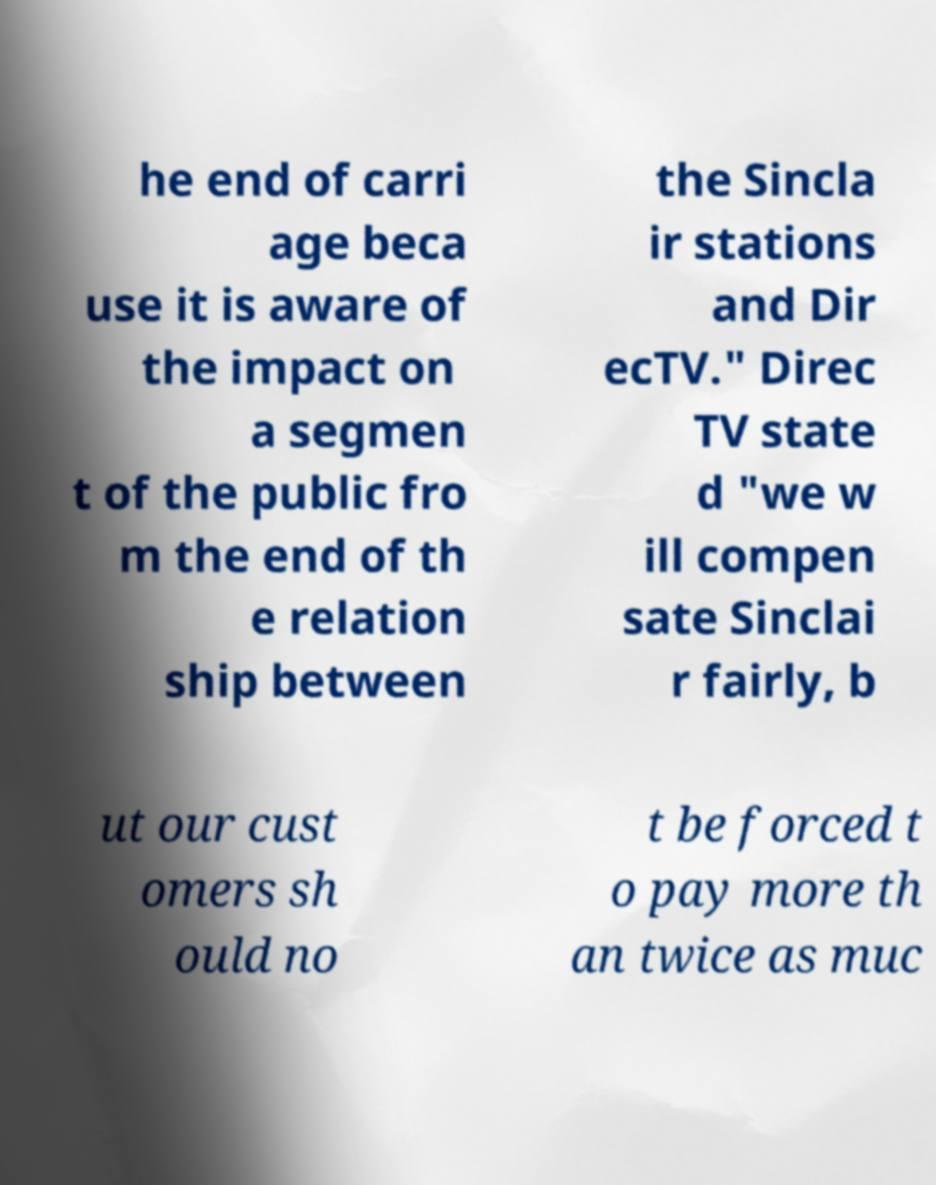For documentation purposes, I need the text within this image transcribed. Could you provide that? he end of carri age beca use it is aware of the impact on a segmen t of the public fro m the end of th e relation ship between the Sincla ir stations and Dir ecTV." Direc TV state d "we w ill compen sate Sinclai r fairly, b ut our cust omers sh ould no t be forced t o pay more th an twice as muc 